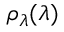<formula> <loc_0><loc_0><loc_500><loc_500>\rho _ { \lambda } ( \lambda )</formula> 